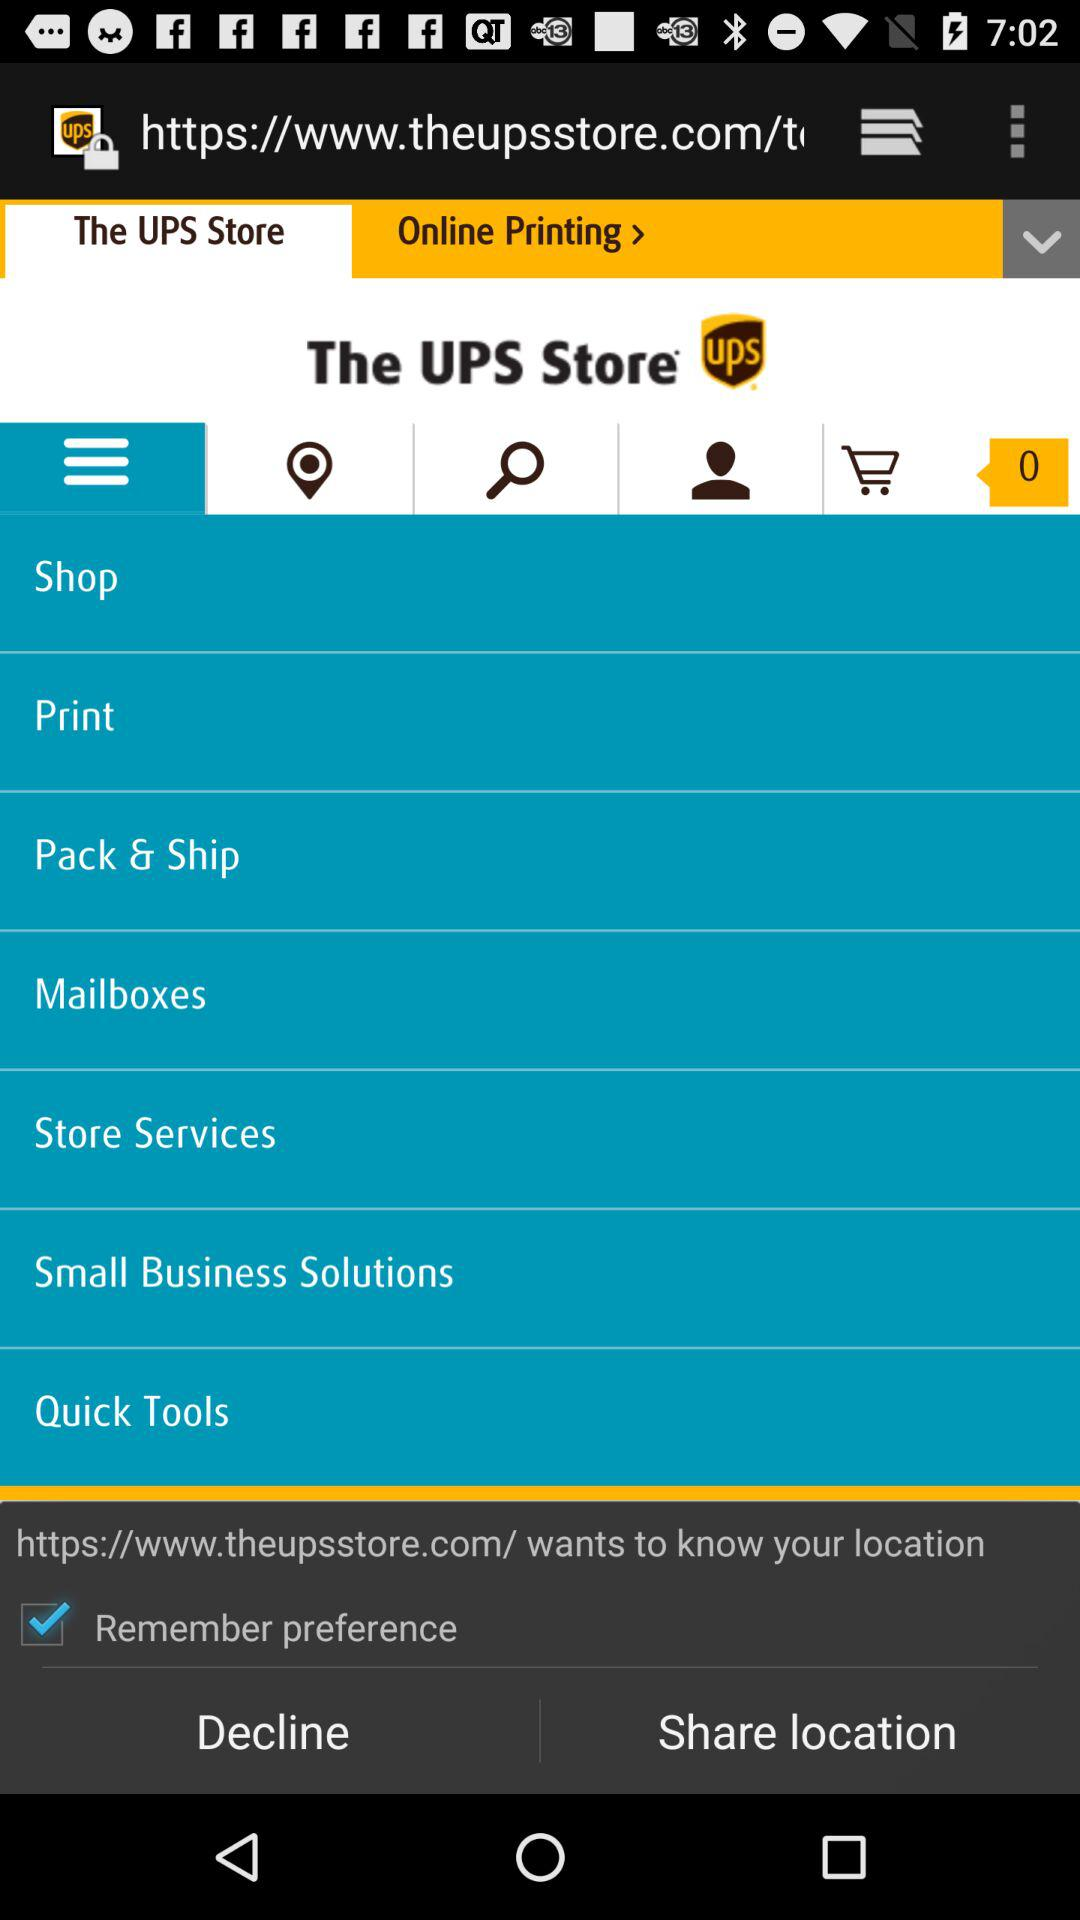What website wants to know our location? The website that wants to know your location is https://www.theupsstore.com/. 